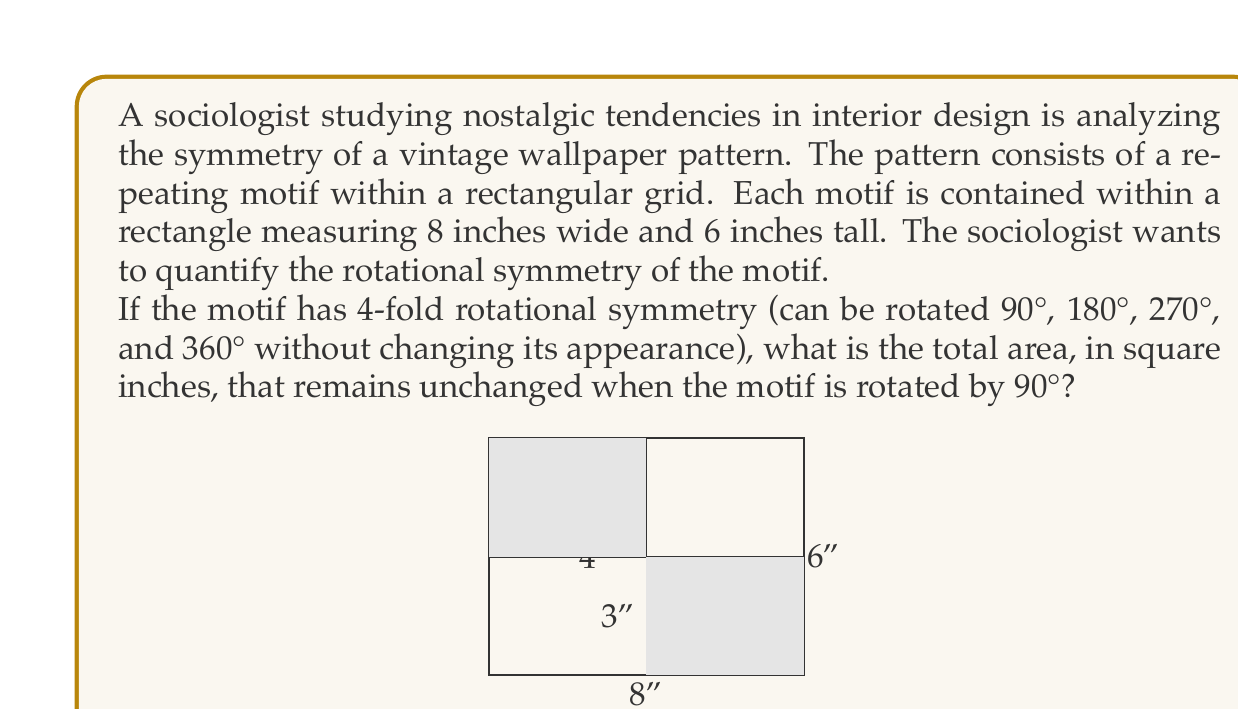Could you help me with this problem? To solve this problem, we need to understand the concept of rotational symmetry and how it applies to the given motif. Let's break it down step-by-step:

1) In a 4-fold rotational symmetry, the motif remains unchanged when rotated by 90°, 180°, 270°, and 360°. This means that the motif must have four identical quadrants.

2) The rectangle containing the motif is 8 inches wide and 6 inches tall. To have 4-fold rotational symmetry, we need to divide this rectangle into four equal parts.

3) To do this, we find the center of the rectangle:
   - Width: 8 ÷ 2 = 4 inches
   - Height: 6 ÷ 2 = 3 inches

4) This creates four smaller rectangles, each measuring 4 inches by 3 inches.

5) When the motif is rotated by 90°, two of these smaller rectangles remain in their original position:
   - The top-left rectangle (0-4 inches wide, 3-6 inches tall)
   - The bottom-right rectangle (4-8 inches wide, 0-3 inches tall)

6) To calculate the area that remains unchanged, we need to find the area of these two rectangles:
   Area of one rectangle = 4 inches × 3 inches = 12 square inches
   Area of two rectangles = 12 square inches × 2 = 24 square inches

Therefore, the total area that remains unchanged when the motif is rotated by 90° is 24 square inches.

This analysis could be valuable for the sociologist to understand how symmetry in vintage patterns might contribute to their appeal and nostalgic value.
Answer: 24 square inches 